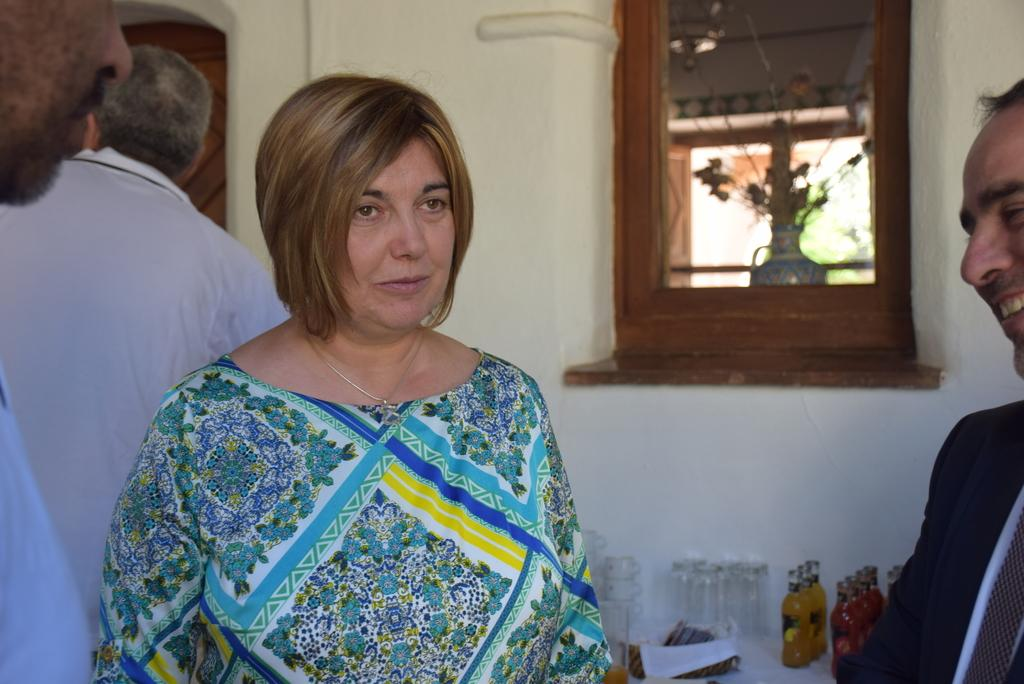Who or what is present in the image? There are people in the image. What items can be seen related to beverages? There are bottles and cups in the image. Are there any other objects visible in the image? Yes, there are other objects in the image. What can be seen in the background of the image? There is a wall and a mirror in the background of the image. What is visible through the mirror? A flower vase is visible through the mirror. What month is it in the image? There is no information about the month in the image. Can you see a cow in the image? There is no cow present in the image. 